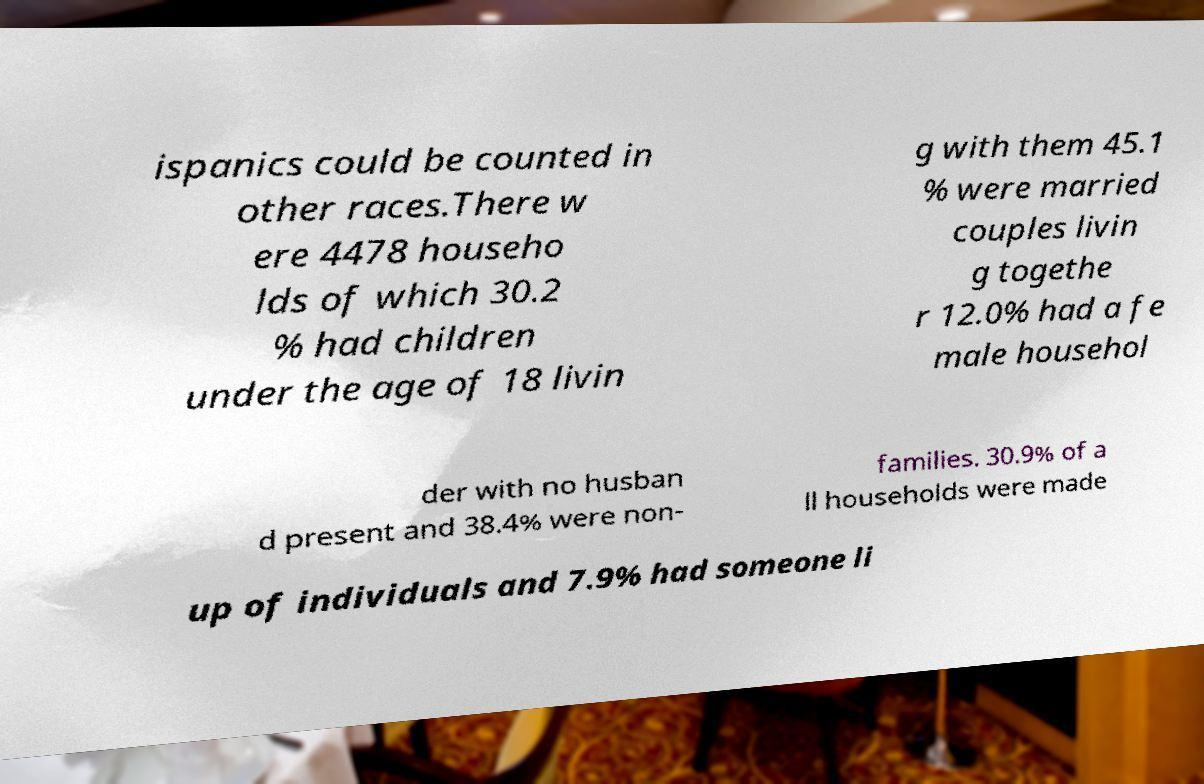For documentation purposes, I need the text within this image transcribed. Could you provide that? ispanics could be counted in other races.There w ere 4478 househo lds of which 30.2 % had children under the age of 18 livin g with them 45.1 % were married couples livin g togethe r 12.0% had a fe male househol der with no husban d present and 38.4% were non- families. 30.9% of a ll households were made up of individuals and 7.9% had someone li 